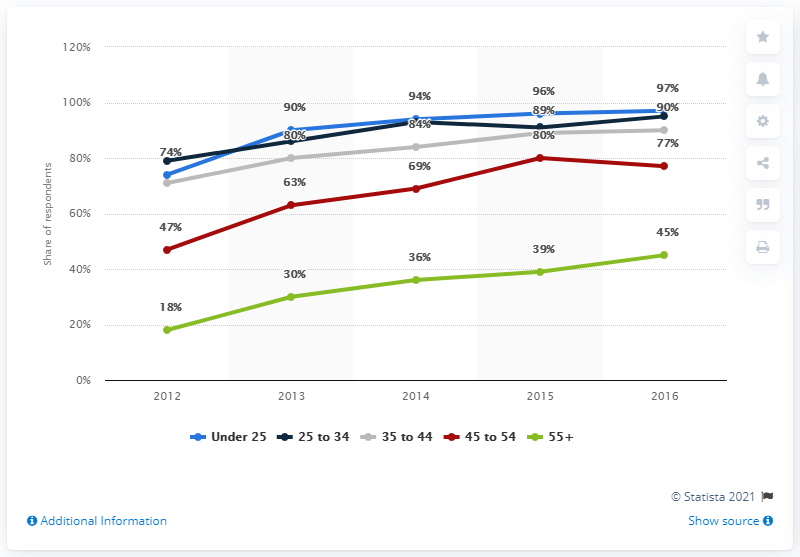Indicate a few pertinent items in this graphic. In 2016, it was determined that the smartphone penetration rate for users under 25 was 97%. In 2012, the share of smartphone users in the UK was released. In 2016, approximately 45% of smartphone users were 55 years of age and older. 